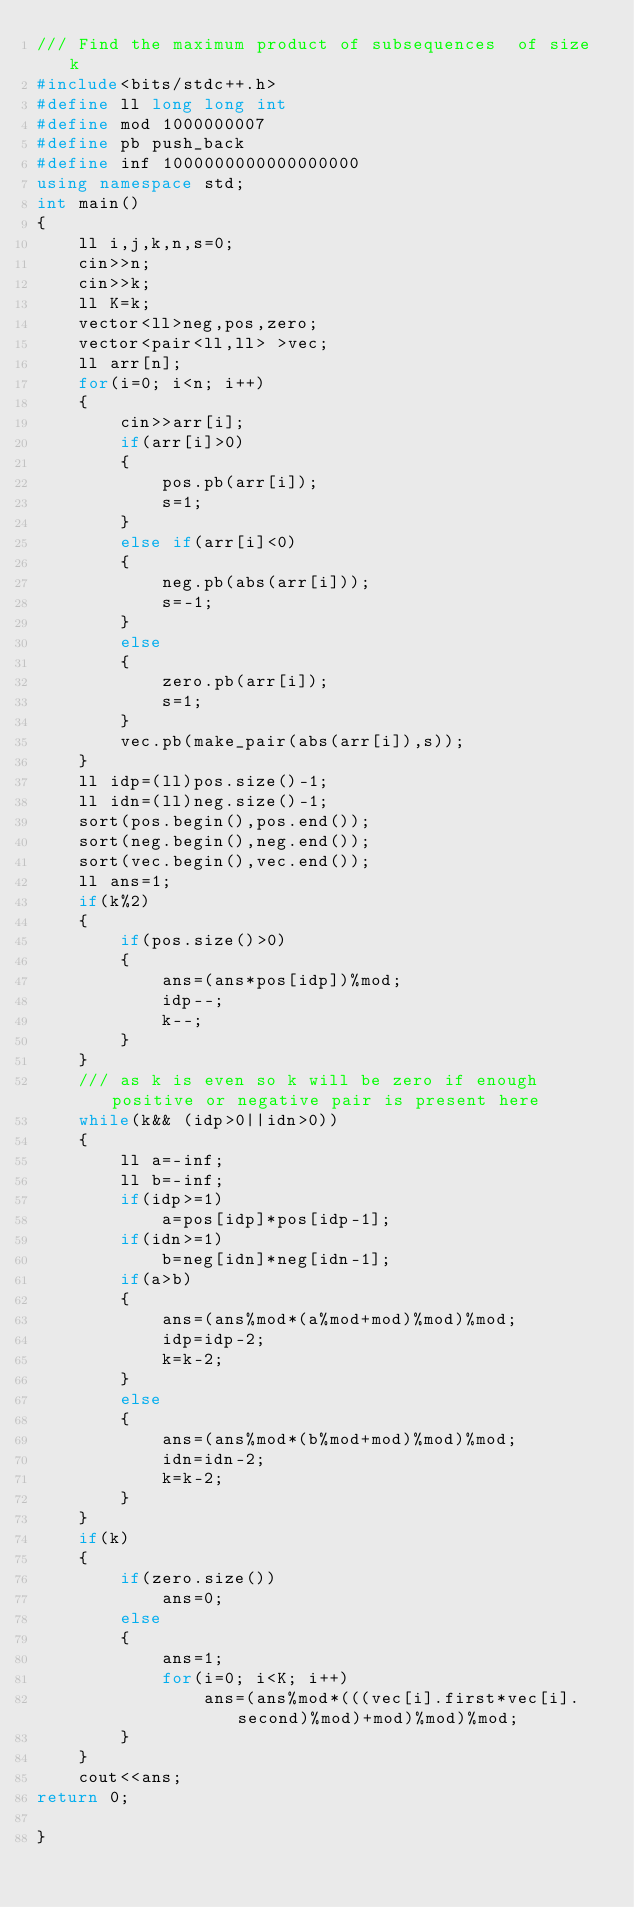Convert code to text. <code><loc_0><loc_0><loc_500><loc_500><_C++_>/// Find the maximum product of subsequences  of size k
#include<bits/stdc++.h>
#define ll long long int
#define mod 1000000007
#define pb push_back
#define inf 1000000000000000000
using namespace std;
int main()
{
    ll i,j,k,n,s=0;
    cin>>n;
    cin>>k;
    ll K=k;
    vector<ll>neg,pos,zero;
    vector<pair<ll,ll> >vec;
    ll arr[n];
    for(i=0; i<n; i++)
    {
        cin>>arr[i];
        if(arr[i]>0)
        {
            pos.pb(arr[i]);
            s=1;
        }
        else if(arr[i]<0)
        {
            neg.pb(abs(arr[i]));
            s=-1;
        }
        else
        {
            zero.pb(arr[i]);
            s=1;
        }
        vec.pb(make_pair(abs(arr[i]),s));
    }
    ll idp=(ll)pos.size()-1;
    ll idn=(ll)neg.size()-1;
    sort(pos.begin(),pos.end());
    sort(neg.begin(),neg.end());
    sort(vec.begin(),vec.end());
    ll ans=1;
    if(k%2)
    {
        if(pos.size()>0)
        {
            ans=(ans*pos[idp])%mod;
            idp--;
            k--;
        }
    }
    /// as k is even so k will be zero if enough positive or negative pair is present here
    while(k&& (idp>0||idn>0))
    {
        ll a=-inf;
        ll b=-inf;
        if(idp>=1)
            a=pos[idp]*pos[idp-1];
        if(idn>=1)
            b=neg[idn]*neg[idn-1];
        if(a>b)
        {
            ans=(ans%mod*(a%mod+mod)%mod)%mod;
            idp=idp-2;
            k=k-2;
        }
        else
        {
            ans=(ans%mod*(b%mod+mod)%mod)%mod;
            idn=idn-2;
            k=k-2;
        }
    }
    if(k)
    {
        if(zero.size())
            ans=0;
        else
        {
            ans=1;
            for(i=0; i<K; i++)
                ans=(ans%mod*(((vec[i].first*vec[i].second)%mod)+mod)%mod)%mod;
        }
    }
    cout<<ans;
return 0;

}
</code> 